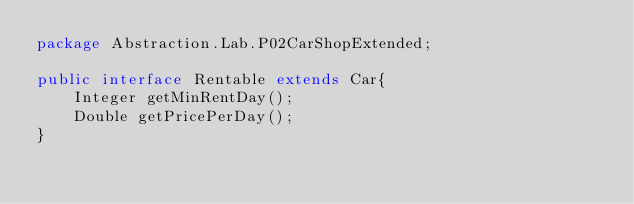Convert code to text. <code><loc_0><loc_0><loc_500><loc_500><_Java_>package Abstraction.Lab.P02CarShopExtended;

public interface Rentable extends Car{
    Integer getMinRentDay();
    Double getPricePerDay();
}
</code> 